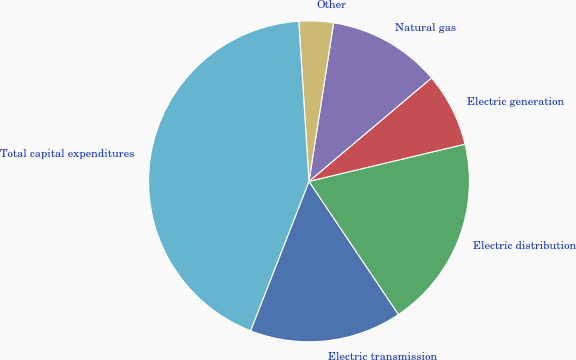Convert chart. <chart><loc_0><loc_0><loc_500><loc_500><pie_chart><fcel>Electric transmission<fcel>Electric distribution<fcel>Electric generation<fcel>Natural gas<fcel>Other<fcel>Total capital expenditures<nl><fcel>15.35%<fcel>19.31%<fcel>7.43%<fcel>11.39%<fcel>3.47%<fcel>43.06%<nl></chart> 